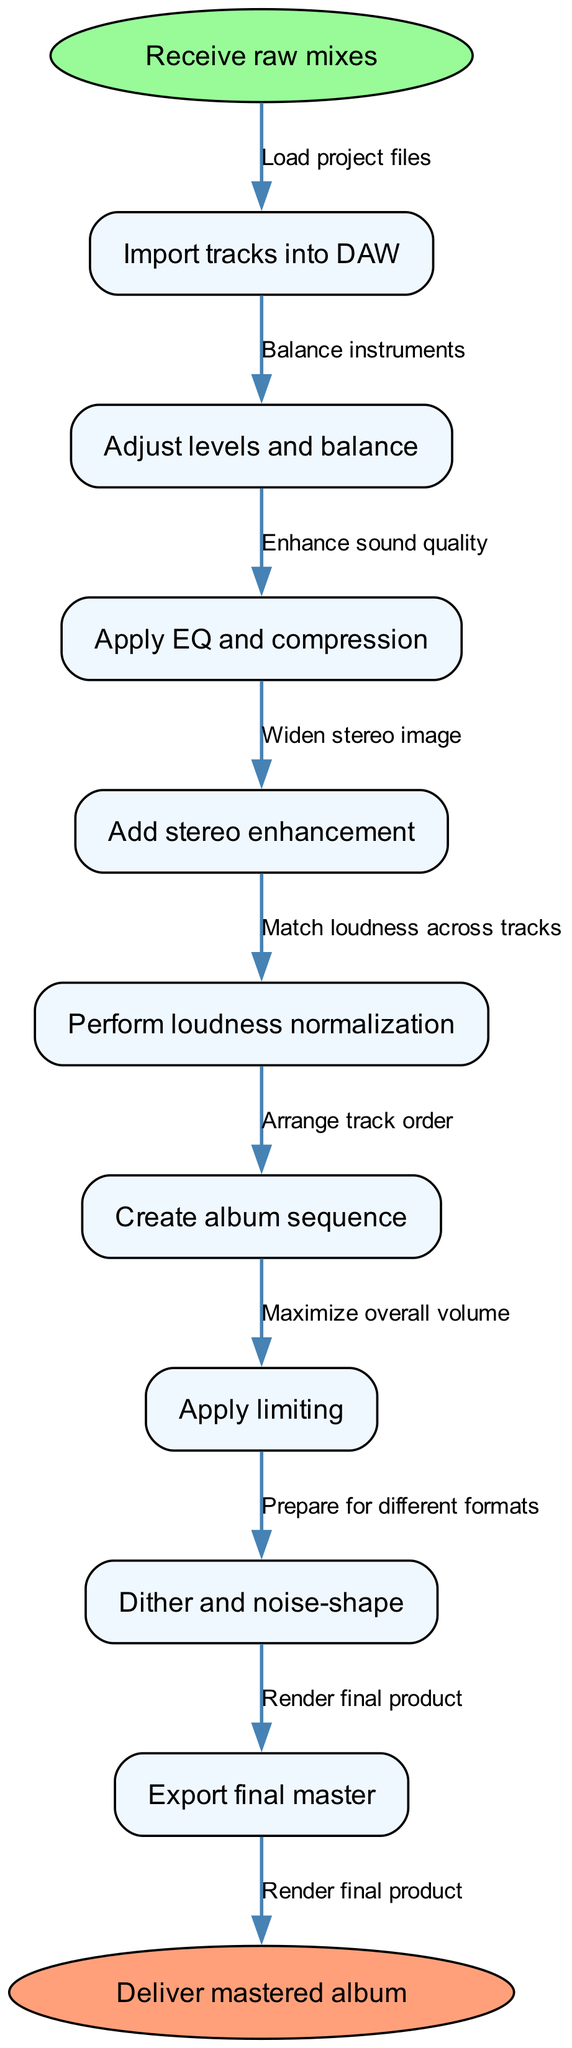What is the first step in the mastering workflow? The first step in the workflow is indicated by the "start" node, which is "Receive raw mixes." This node represents the initiation of the mastering process.
Answer: Receive raw mixes How many process nodes are there in the diagram? By counting the nodes listed after the start node, there are 9 process nodes that represent the various steps in the mastering workflow.
Answer: 9 What is the last process before delivery? The last node before reaching the end node is "Export final master." This indicates the final step taken in the mastering workflow prior to delivering the album.
Answer: Export final master What is the relationship between “Apply EQ and compression” and “Add stereo enhancement”? The edge connecting "Apply EQ and compression" to "Add stereo enhancement" shows a direct flow from one process to another. The workflow follows a logical order, indicating that stereo enhancement comes after EQ and compression adjustments.
Answer: Enhance sound quality Which step ensures consistent volume levels across all tracks? The step that specifies matching loudness across tracks is "Perform loudness normalization." This step is crucial for ensuring that all tracks have a consistent volume level when the album is played.
Answer: Perform loudness normalization What is the purpose of the edge labeled "Balance instruments"? The edge "Balance instruments" represents the action taken in the second process, "Adjust levels and balance," where the engineer balances the instrumental parts of the track before moving on in the flow.
Answer: Adjust levels and balance Which step comes after “Create album sequence”? The node following "Create album sequence" connects to "Apply limiting." This indicates the next action in the workflow that occurs after arranging the track order.
Answer: Apply limiting What do we do to prepare for different formats? The process that prepares the final product for different formats is "Dither and noise-shape." This step ensures that the audio is suitable for various playback systems and media formats.
Answer: Dither and noise-shape Identify the final output of the process. The last node in the diagram before reaching the end is "Export final master," which indicates that the output of the mastering process is the finished master version of the album to be delivered.
Answer: Deliver mastered album 